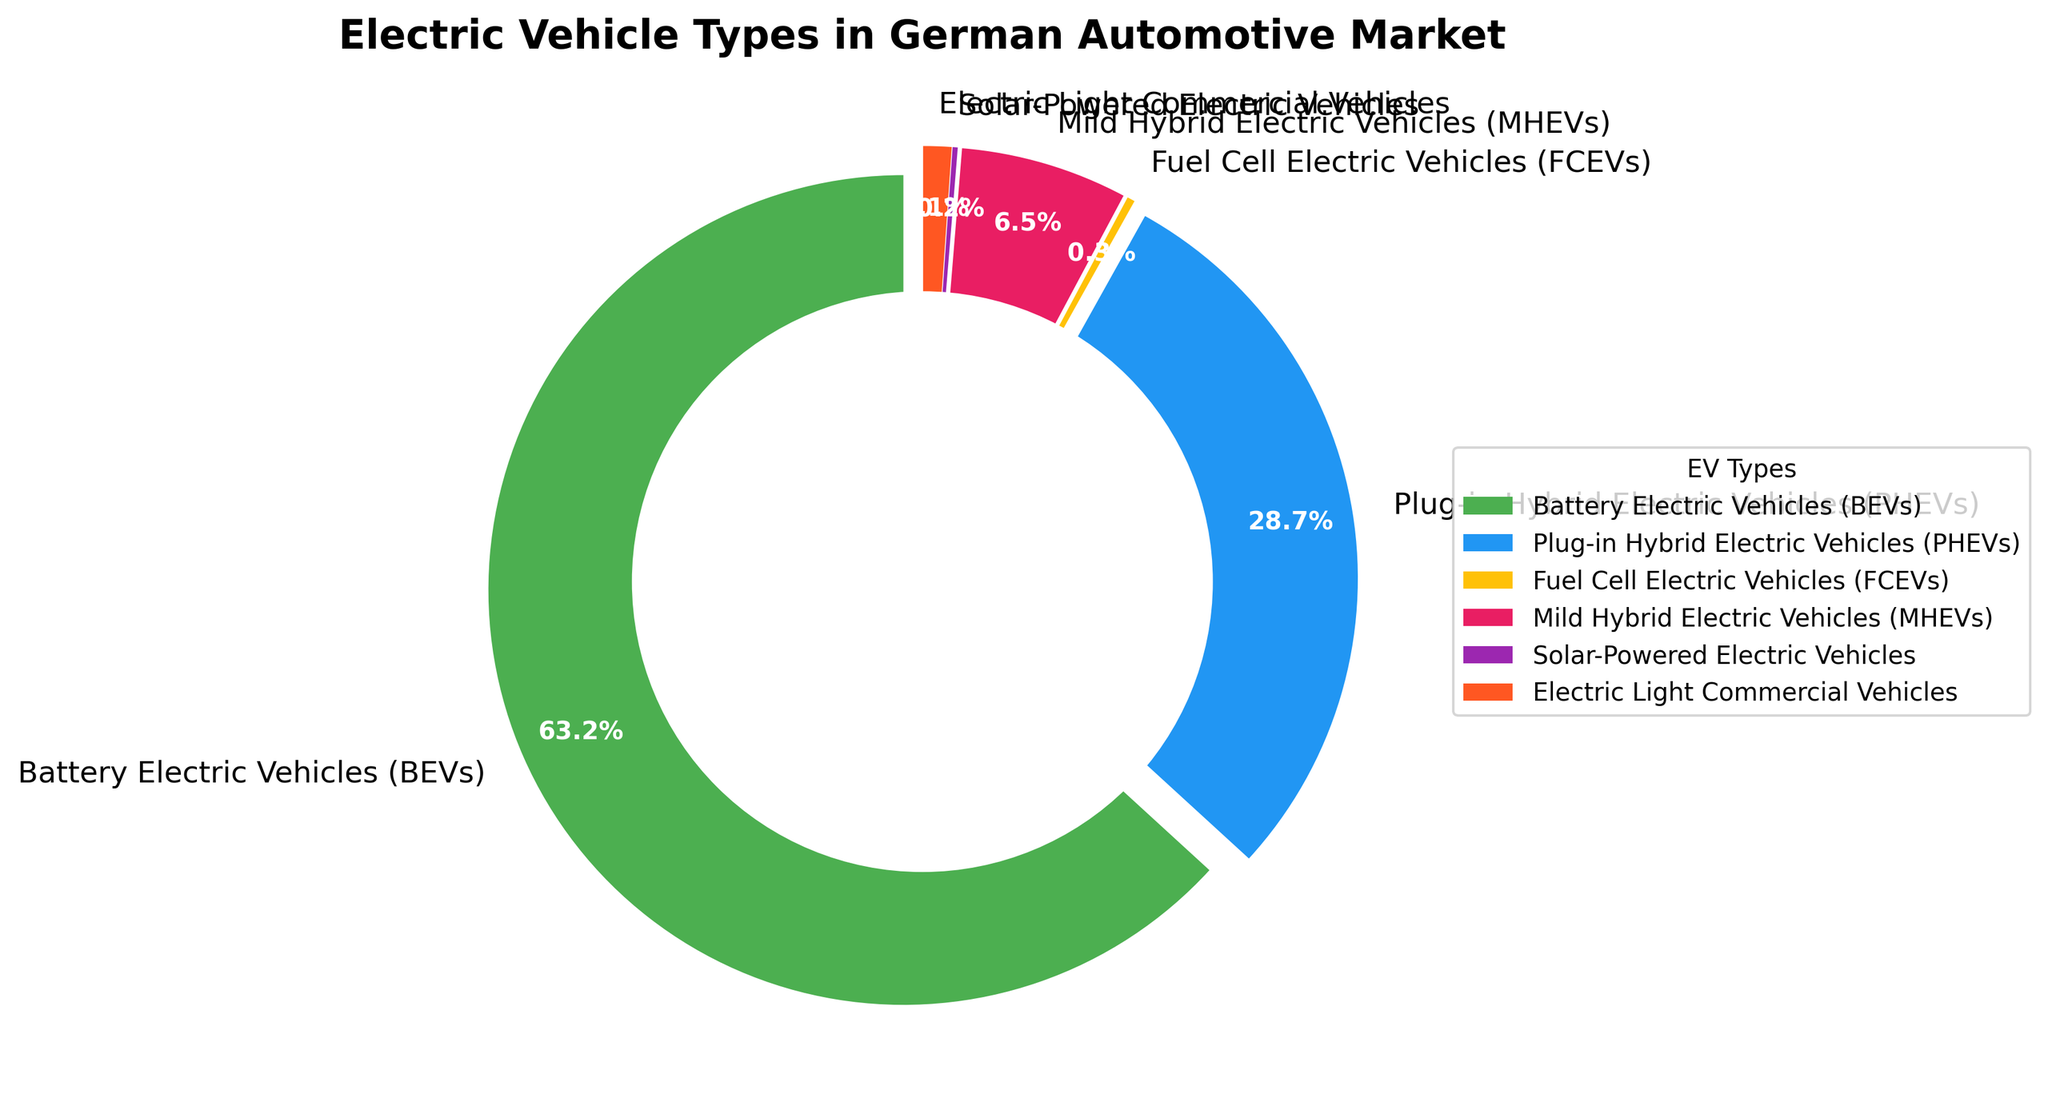What percentage of electric vehicles in the German automotive market are either Battery Electric Vehicles (BEVs) or Plug-in Hybrid Electric Vehicles (PHEVs)? To find the percentage of BEVs and PHEVs combined, sum their individual percentages: BEVs (63.2%) + PHEVs (28.7%) = 91.9%
Answer: 91.9% Which type of electric vehicle has the smallest market share? By visually inspecting the pie chart, we can see that the segment for solar-powered electric vehicles is the smallest at 0.2%
Answer: Solar-Powered Electric Vehicles Between BEVs and PHEVs, which has the larger market share, and by how much? BEVs have a market share of 63.2%, while PHEVs have 28.7%. The difference is 63.2% - 28.7% = 34.5%
Answer: BEVs by 34.5% What is the combined market share of Fuel Cell Electric Vehicles (FCEVs) and Solar-Powered Electric Vehicles? Add the percentages of FCEVs (0.3%) and Solar-Powered Electric Vehicles (0.2%): 0.3% + 0.2% = 0.5%
Answer: 0.5% How does the market share of Mild Hybrid Electric Vehicles (MHEVs) compare to that of Electric Light Commercial Vehicles? MHEVs have a market share of 6.5%, while Electric Light Commercial Vehicles have 1.1%. Since 6.5% is greater than 1.1%, MHEVs have a larger market share
Answer: MHEVs have a larger market share What fraction of the market do BEVs compose relative to MHEVs? The share of BEVs (63.2%) relative to MHEVs (6.5%) can be calculated by dividing their percentages: 63.2/6.5 ≈ 9.72. This means BEVs have approximately 9.72 times the market share of MHEVs
Answer: ~9.72 times Which segment represents a larger share of the market: BEVs or the combined share of PHEVs and MHEVs? The combined share of PHEVs (28.7%) and MHEVs (6.5%) is 28.7% + 6.5% = 35.2%. BEVs have a market share of 63.2%, which is larger
Answer: BEVs If the market share of Solar-Powered Electric Vehicles doubled, what would their new percentage be, and would it still be the smallest segment? If the market share doubles from 0.2%, it becomes 0.4%. Even after doubling, Fuel Cell Electric Vehicles (FCEVs) remain at 0.3%, which is still larger than 0.4%, so it remains the smallest segment
Answer: 0.4%, and Yes What portion of the pie chart is occupied by electric vehicle types other than BEVs and PHEVs? Total remaining percentage is calculated by subtracting the combined share of BEVs and PHEVs from 100%: 100% - 91.9% = 8.1%
Answer: 8.1% 